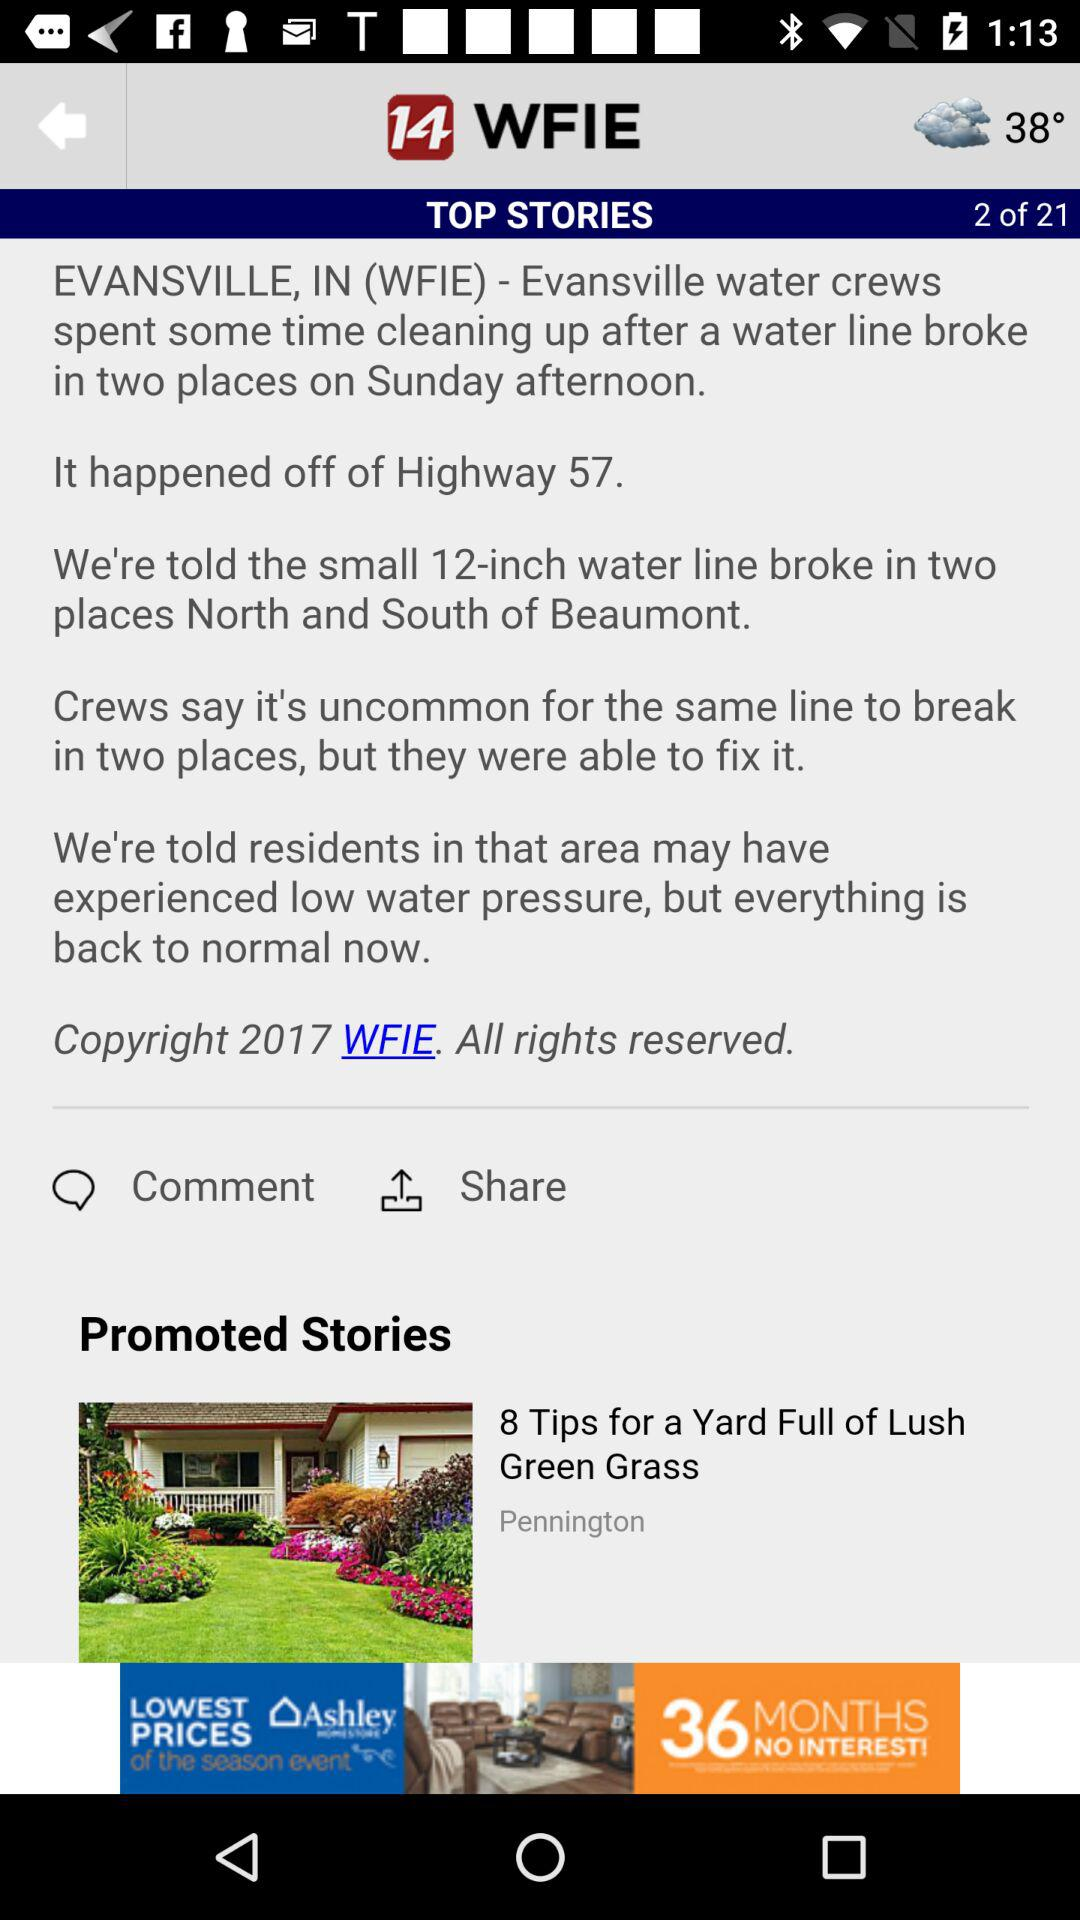How many pages are there in "TOP STORIES"? There are 21 pages. 